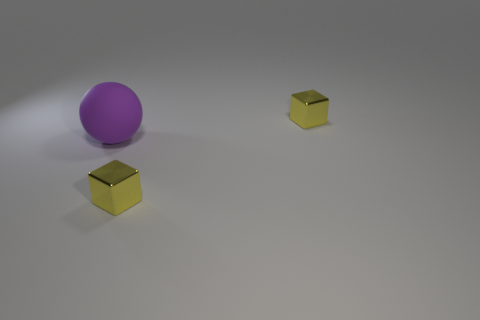How does the lighting in the image affect the perception of the objects? The lighting in the image creates soft shadows and highlights on the objects, which contributes to a sense of depth and dimensionality. The reflective surfaces of the purple ball and golden cubes interact with the light, showcasing their shiny textures and adding to the overall visual appeal. The direction of the light also appears to come from the upper left, indicating a single diffuse light source, which gives the scene a calm and contemplative atmosphere. 